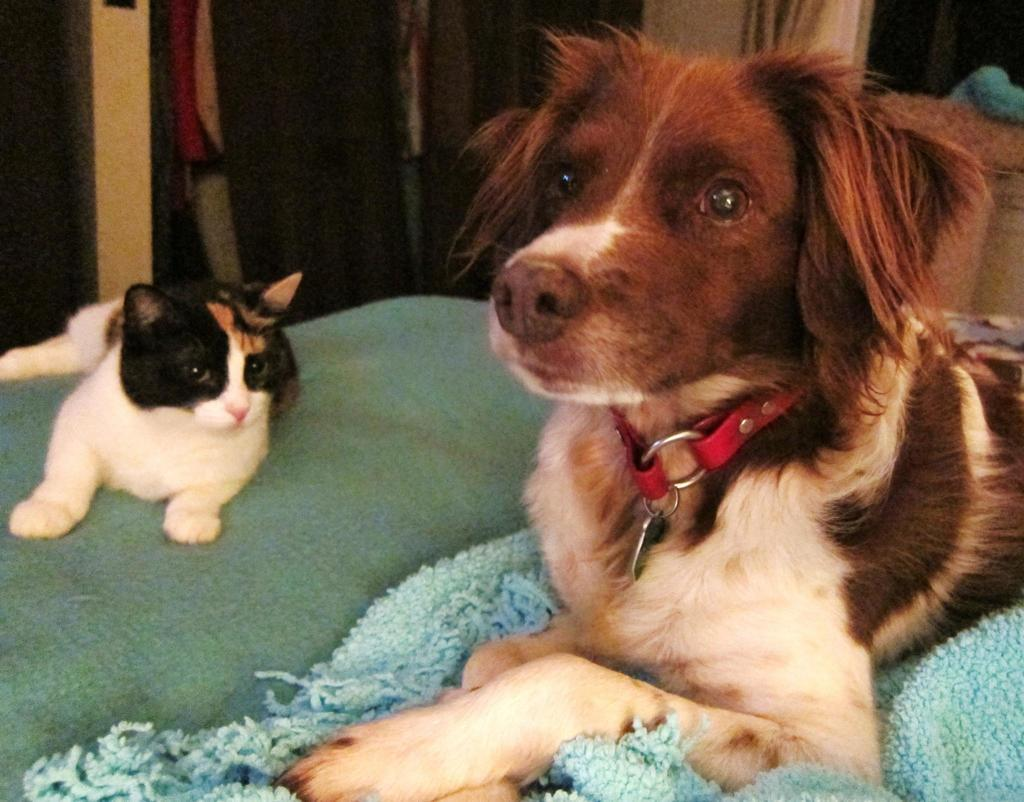What is located in the front of the image? There are animals in the front of the image. What can be seen in the background of the image? There are objects in the background of the image. What colors are the objects in the background? The objects in the background have black, red, and cream colors. Who is the creator of the animals in the image? The image does not provide information about the creator of the animals. Is there any mention of payment in the image? There is no mention of payment in the image. 